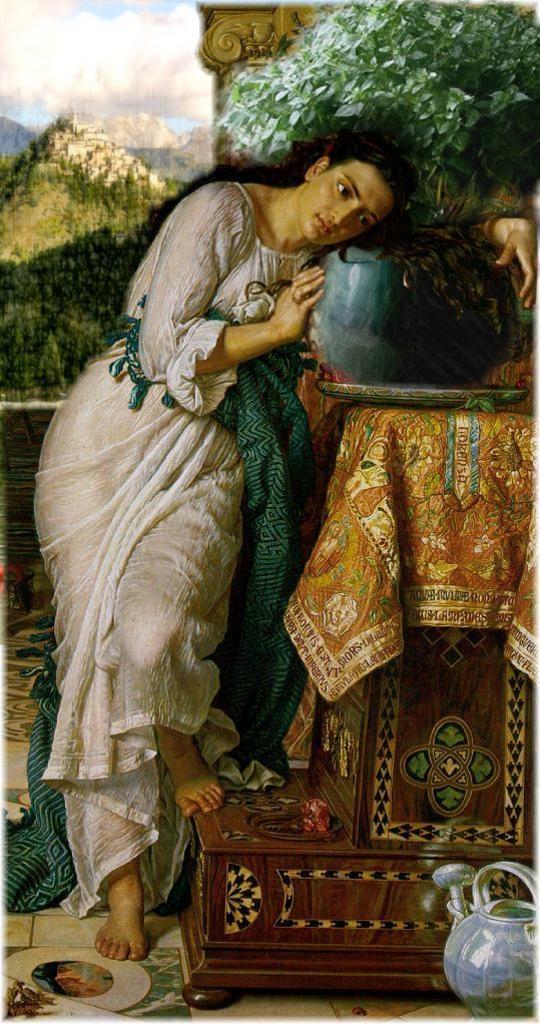Please provide a concise description of this image. In this image we can see a painting of a girl holding a flower pot, which is placed on a table covered with a cloth, at bottom right corner of a picture we can see a pot, and behind the girl we can see some mountains trees, and clouded sky. 